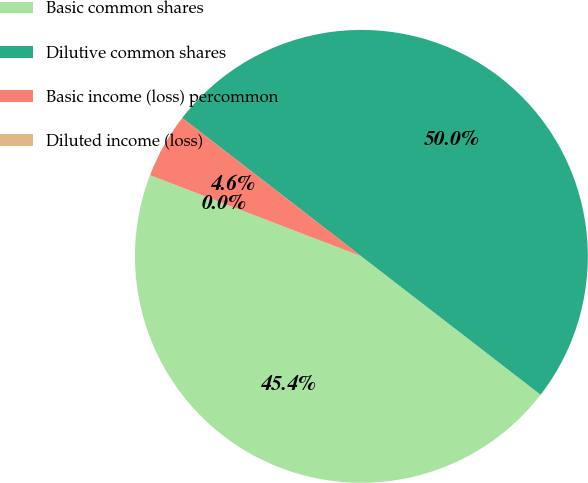Convert chart. <chart><loc_0><loc_0><loc_500><loc_500><pie_chart><fcel>Basic common shares<fcel>Dilutive common shares<fcel>Basic income (loss) percommon<fcel>Diluted income (loss)<nl><fcel>45.37%<fcel>50.0%<fcel>4.63%<fcel>0.0%<nl></chart> 